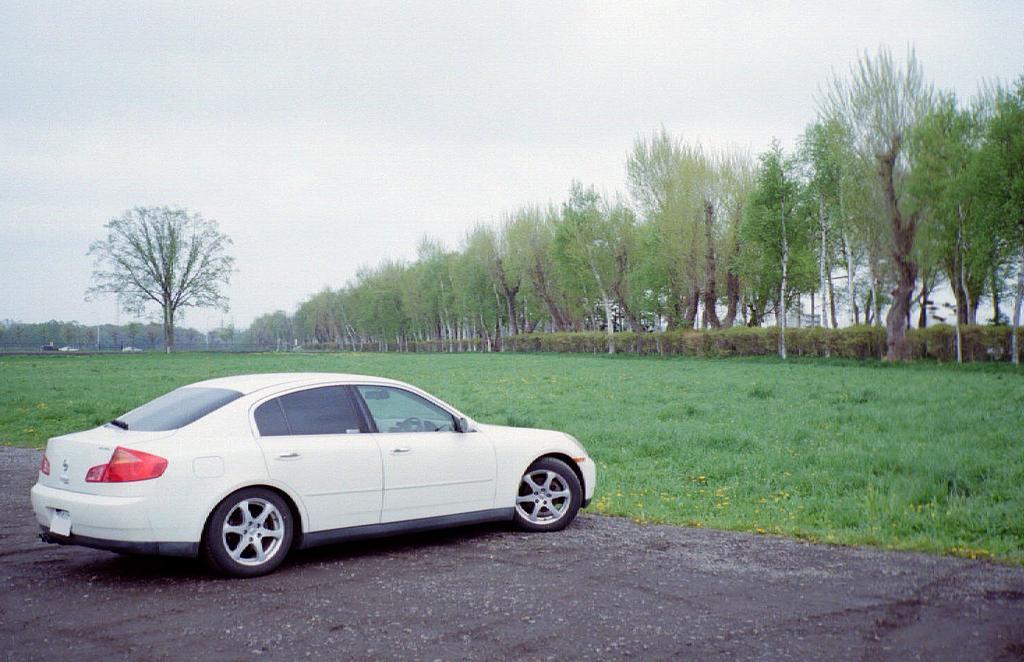In one or two sentences, can you explain what this image depicts? In the image we can see there is a white colour car standing on the road. The ground is covered with grass and there are lot of trees. 